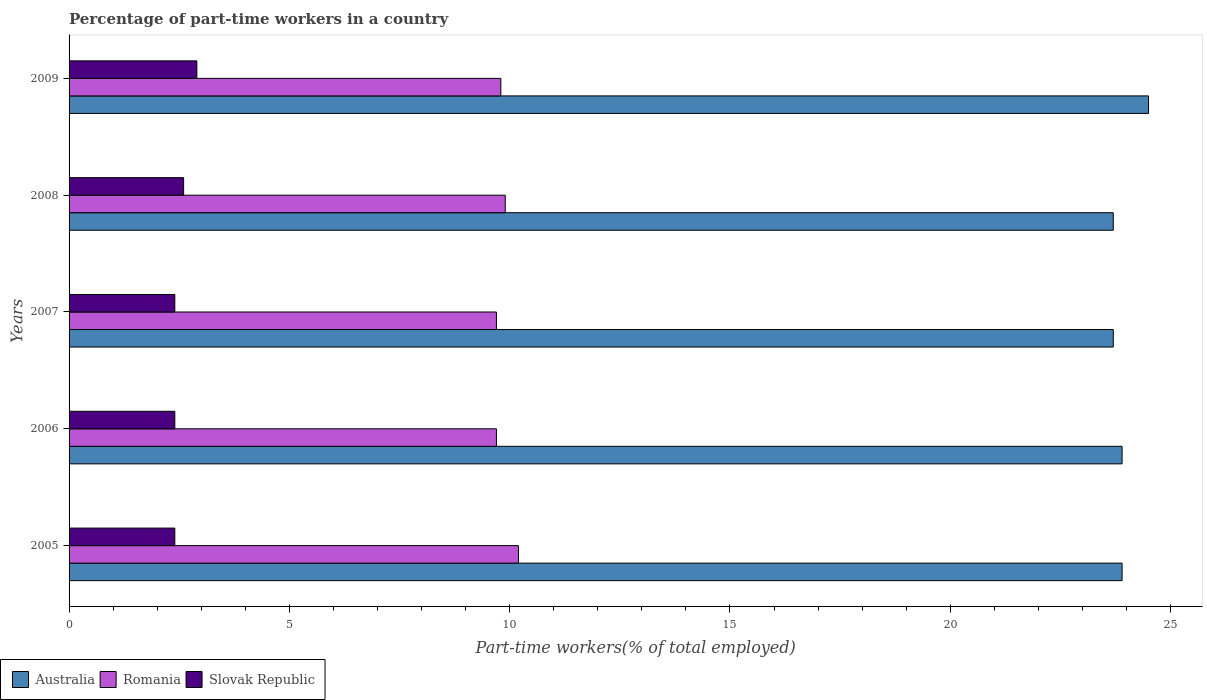Are the number of bars per tick equal to the number of legend labels?
Provide a succinct answer. Yes. Are the number of bars on each tick of the Y-axis equal?
Make the answer very short. Yes. What is the percentage of part-time workers in Slovak Republic in 2005?
Offer a very short reply. 2.4. Across all years, what is the maximum percentage of part-time workers in Romania?
Your answer should be compact. 10.2. Across all years, what is the minimum percentage of part-time workers in Romania?
Offer a very short reply. 9.7. In which year was the percentage of part-time workers in Slovak Republic maximum?
Offer a terse response. 2009. In which year was the percentage of part-time workers in Romania minimum?
Ensure brevity in your answer.  2006. What is the total percentage of part-time workers in Slovak Republic in the graph?
Make the answer very short. 12.7. What is the difference between the percentage of part-time workers in Romania in 2007 and that in 2009?
Your answer should be very brief. -0.1. What is the difference between the percentage of part-time workers in Australia in 2006 and the percentage of part-time workers in Slovak Republic in 2008?
Keep it short and to the point. 21.3. What is the average percentage of part-time workers in Romania per year?
Make the answer very short. 9.86. In the year 2005, what is the difference between the percentage of part-time workers in Slovak Republic and percentage of part-time workers in Romania?
Offer a terse response. -7.8. What is the ratio of the percentage of part-time workers in Australia in 2005 to that in 2008?
Your answer should be compact. 1.01. Is the percentage of part-time workers in Australia in 2007 less than that in 2009?
Give a very brief answer. Yes. What is the difference between the highest and the second highest percentage of part-time workers in Romania?
Offer a very short reply. 0.3. What is the difference between the highest and the lowest percentage of part-time workers in Australia?
Ensure brevity in your answer.  0.8. What does the 1st bar from the top in 2006 represents?
Ensure brevity in your answer.  Slovak Republic. What does the 2nd bar from the bottom in 2005 represents?
Your response must be concise. Romania. Is it the case that in every year, the sum of the percentage of part-time workers in Slovak Republic and percentage of part-time workers in Australia is greater than the percentage of part-time workers in Romania?
Your response must be concise. Yes. How many bars are there?
Provide a short and direct response. 15. Are all the bars in the graph horizontal?
Your answer should be very brief. Yes. What is the title of the graph?
Your answer should be very brief. Percentage of part-time workers in a country. What is the label or title of the X-axis?
Your answer should be compact. Part-time workers(% of total employed). What is the Part-time workers(% of total employed) in Australia in 2005?
Give a very brief answer. 23.9. What is the Part-time workers(% of total employed) in Romania in 2005?
Ensure brevity in your answer.  10.2. What is the Part-time workers(% of total employed) of Slovak Republic in 2005?
Offer a terse response. 2.4. What is the Part-time workers(% of total employed) of Australia in 2006?
Make the answer very short. 23.9. What is the Part-time workers(% of total employed) of Romania in 2006?
Your answer should be compact. 9.7. What is the Part-time workers(% of total employed) of Slovak Republic in 2006?
Offer a very short reply. 2.4. What is the Part-time workers(% of total employed) of Australia in 2007?
Offer a very short reply. 23.7. What is the Part-time workers(% of total employed) of Romania in 2007?
Your answer should be very brief. 9.7. What is the Part-time workers(% of total employed) of Slovak Republic in 2007?
Keep it short and to the point. 2.4. What is the Part-time workers(% of total employed) in Australia in 2008?
Make the answer very short. 23.7. What is the Part-time workers(% of total employed) in Romania in 2008?
Offer a terse response. 9.9. What is the Part-time workers(% of total employed) of Slovak Republic in 2008?
Provide a succinct answer. 2.6. What is the Part-time workers(% of total employed) of Romania in 2009?
Your answer should be compact. 9.8. What is the Part-time workers(% of total employed) of Slovak Republic in 2009?
Keep it short and to the point. 2.9. Across all years, what is the maximum Part-time workers(% of total employed) in Romania?
Ensure brevity in your answer.  10.2. Across all years, what is the maximum Part-time workers(% of total employed) of Slovak Republic?
Offer a very short reply. 2.9. Across all years, what is the minimum Part-time workers(% of total employed) of Australia?
Make the answer very short. 23.7. Across all years, what is the minimum Part-time workers(% of total employed) of Romania?
Your answer should be very brief. 9.7. Across all years, what is the minimum Part-time workers(% of total employed) of Slovak Republic?
Offer a very short reply. 2.4. What is the total Part-time workers(% of total employed) of Australia in the graph?
Offer a terse response. 119.7. What is the total Part-time workers(% of total employed) of Romania in the graph?
Keep it short and to the point. 49.3. What is the difference between the Part-time workers(% of total employed) in Romania in 2005 and that in 2006?
Provide a short and direct response. 0.5. What is the difference between the Part-time workers(% of total employed) in Slovak Republic in 2005 and that in 2006?
Offer a very short reply. 0. What is the difference between the Part-time workers(% of total employed) in Australia in 2005 and that in 2007?
Ensure brevity in your answer.  0.2. What is the difference between the Part-time workers(% of total employed) of Slovak Republic in 2005 and that in 2007?
Your response must be concise. 0. What is the difference between the Part-time workers(% of total employed) of Romania in 2005 and that in 2008?
Provide a short and direct response. 0.3. What is the difference between the Part-time workers(% of total employed) in Australia in 2005 and that in 2009?
Offer a very short reply. -0.6. What is the difference between the Part-time workers(% of total employed) of Romania in 2005 and that in 2009?
Your answer should be compact. 0.4. What is the difference between the Part-time workers(% of total employed) of Slovak Republic in 2005 and that in 2009?
Offer a very short reply. -0.5. What is the difference between the Part-time workers(% of total employed) in Australia in 2006 and that in 2007?
Offer a terse response. 0.2. What is the difference between the Part-time workers(% of total employed) of Australia in 2006 and that in 2008?
Your response must be concise. 0.2. What is the difference between the Part-time workers(% of total employed) of Slovak Republic in 2006 and that in 2008?
Provide a succinct answer. -0.2. What is the difference between the Part-time workers(% of total employed) in Australia in 2006 and that in 2009?
Ensure brevity in your answer.  -0.6. What is the difference between the Part-time workers(% of total employed) in Romania in 2006 and that in 2009?
Your response must be concise. -0.1. What is the difference between the Part-time workers(% of total employed) in Slovak Republic in 2006 and that in 2009?
Offer a very short reply. -0.5. What is the difference between the Part-time workers(% of total employed) of Australia in 2007 and that in 2008?
Your answer should be compact. 0. What is the difference between the Part-time workers(% of total employed) in Australia in 2008 and that in 2009?
Ensure brevity in your answer.  -0.8. What is the difference between the Part-time workers(% of total employed) in Slovak Republic in 2008 and that in 2009?
Ensure brevity in your answer.  -0.3. What is the difference between the Part-time workers(% of total employed) in Australia in 2005 and the Part-time workers(% of total employed) in Romania in 2006?
Give a very brief answer. 14.2. What is the difference between the Part-time workers(% of total employed) in Australia in 2005 and the Part-time workers(% of total employed) in Slovak Republic in 2006?
Offer a terse response. 21.5. What is the difference between the Part-time workers(% of total employed) in Romania in 2005 and the Part-time workers(% of total employed) in Slovak Republic in 2006?
Make the answer very short. 7.8. What is the difference between the Part-time workers(% of total employed) in Australia in 2005 and the Part-time workers(% of total employed) in Romania in 2007?
Offer a very short reply. 14.2. What is the difference between the Part-time workers(% of total employed) of Australia in 2005 and the Part-time workers(% of total employed) of Slovak Republic in 2007?
Offer a very short reply. 21.5. What is the difference between the Part-time workers(% of total employed) of Australia in 2005 and the Part-time workers(% of total employed) of Romania in 2008?
Make the answer very short. 14. What is the difference between the Part-time workers(% of total employed) of Australia in 2005 and the Part-time workers(% of total employed) of Slovak Republic in 2008?
Offer a terse response. 21.3. What is the difference between the Part-time workers(% of total employed) in Australia in 2005 and the Part-time workers(% of total employed) in Slovak Republic in 2009?
Your answer should be very brief. 21. What is the difference between the Part-time workers(% of total employed) of Romania in 2005 and the Part-time workers(% of total employed) of Slovak Republic in 2009?
Offer a very short reply. 7.3. What is the difference between the Part-time workers(% of total employed) in Australia in 2006 and the Part-time workers(% of total employed) in Romania in 2007?
Your answer should be compact. 14.2. What is the difference between the Part-time workers(% of total employed) of Romania in 2006 and the Part-time workers(% of total employed) of Slovak Republic in 2007?
Provide a succinct answer. 7.3. What is the difference between the Part-time workers(% of total employed) in Australia in 2006 and the Part-time workers(% of total employed) in Romania in 2008?
Provide a short and direct response. 14. What is the difference between the Part-time workers(% of total employed) in Australia in 2006 and the Part-time workers(% of total employed) in Slovak Republic in 2008?
Offer a very short reply. 21.3. What is the difference between the Part-time workers(% of total employed) in Australia in 2006 and the Part-time workers(% of total employed) in Romania in 2009?
Offer a terse response. 14.1. What is the difference between the Part-time workers(% of total employed) in Romania in 2006 and the Part-time workers(% of total employed) in Slovak Republic in 2009?
Provide a short and direct response. 6.8. What is the difference between the Part-time workers(% of total employed) of Australia in 2007 and the Part-time workers(% of total employed) of Slovak Republic in 2008?
Your answer should be very brief. 21.1. What is the difference between the Part-time workers(% of total employed) in Australia in 2007 and the Part-time workers(% of total employed) in Slovak Republic in 2009?
Provide a succinct answer. 20.8. What is the difference between the Part-time workers(% of total employed) in Romania in 2007 and the Part-time workers(% of total employed) in Slovak Republic in 2009?
Your answer should be very brief. 6.8. What is the difference between the Part-time workers(% of total employed) of Australia in 2008 and the Part-time workers(% of total employed) of Romania in 2009?
Provide a succinct answer. 13.9. What is the difference between the Part-time workers(% of total employed) of Australia in 2008 and the Part-time workers(% of total employed) of Slovak Republic in 2009?
Your response must be concise. 20.8. What is the average Part-time workers(% of total employed) in Australia per year?
Your response must be concise. 23.94. What is the average Part-time workers(% of total employed) of Romania per year?
Offer a terse response. 9.86. What is the average Part-time workers(% of total employed) of Slovak Republic per year?
Your answer should be very brief. 2.54. In the year 2005, what is the difference between the Part-time workers(% of total employed) in Australia and Part-time workers(% of total employed) in Romania?
Make the answer very short. 13.7. In the year 2005, what is the difference between the Part-time workers(% of total employed) in Romania and Part-time workers(% of total employed) in Slovak Republic?
Offer a terse response. 7.8. In the year 2006, what is the difference between the Part-time workers(% of total employed) of Australia and Part-time workers(% of total employed) of Slovak Republic?
Offer a terse response. 21.5. In the year 2006, what is the difference between the Part-time workers(% of total employed) of Romania and Part-time workers(% of total employed) of Slovak Republic?
Provide a succinct answer. 7.3. In the year 2007, what is the difference between the Part-time workers(% of total employed) of Australia and Part-time workers(% of total employed) of Romania?
Your response must be concise. 14. In the year 2007, what is the difference between the Part-time workers(% of total employed) in Australia and Part-time workers(% of total employed) in Slovak Republic?
Keep it short and to the point. 21.3. In the year 2007, what is the difference between the Part-time workers(% of total employed) in Romania and Part-time workers(% of total employed) in Slovak Republic?
Make the answer very short. 7.3. In the year 2008, what is the difference between the Part-time workers(% of total employed) in Australia and Part-time workers(% of total employed) in Slovak Republic?
Provide a succinct answer. 21.1. In the year 2009, what is the difference between the Part-time workers(% of total employed) in Australia and Part-time workers(% of total employed) in Romania?
Your answer should be very brief. 14.7. In the year 2009, what is the difference between the Part-time workers(% of total employed) in Australia and Part-time workers(% of total employed) in Slovak Republic?
Your response must be concise. 21.6. What is the ratio of the Part-time workers(% of total employed) in Romania in 2005 to that in 2006?
Ensure brevity in your answer.  1.05. What is the ratio of the Part-time workers(% of total employed) in Slovak Republic in 2005 to that in 2006?
Give a very brief answer. 1. What is the ratio of the Part-time workers(% of total employed) of Australia in 2005 to that in 2007?
Offer a terse response. 1.01. What is the ratio of the Part-time workers(% of total employed) of Romania in 2005 to that in 2007?
Make the answer very short. 1.05. What is the ratio of the Part-time workers(% of total employed) in Australia in 2005 to that in 2008?
Your response must be concise. 1.01. What is the ratio of the Part-time workers(% of total employed) of Romania in 2005 to that in 2008?
Make the answer very short. 1.03. What is the ratio of the Part-time workers(% of total employed) in Australia in 2005 to that in 2009?
Ensure brevity in your answer.  0.98. What is the ratio of the Part-time workers(% of total employed) in Romania in 2005 to that in 2009?
Your answer should be very brief. 1.04. What is the ratio of the Part-time workers(% of total employed) in Slovak Republic in 2005 to that in 2009?
Offer a terse response. 0.83. What is the ratio of the Part-time workers(% of total employed) of Australia in 2006 to that in 2007?
Keep it short and to the point. 1.01. What is the ratio of the Part-time workers(% of total employed) of Slovak Republic in 2006 to that in 2007?
Keep it short and to the point. 1. What is the ratio of the Part-time workers(% of total employed) of Australia in 2006 to that in 2008?
Offer a very short reply. 1.01. What is the ratio of the Part-time workers(% of total employed) of Romania in 2006 to that in 2008?
Give a very brief answer. 0.98. What is the ratio of the Part-time workers(% of total employed) of Australia in 2006 to that in 2009?
Make the answer very short. 0.98. What is the ratio of the Part-time workers(% of total employed) in Romania in 2006 to that in 2009?
Provide a succinct answer. 0.99. What is the ratio of the Part-time workers(% of total employed) of Slovak Republic in 2006 to that in 2009?
Offer a terse response. 0.83. What is the ratio of the Part-time workers(% of total employed) in Romania in 2007 to that in 2008?
Offer a very short reply. 0.98. What is the ratio of the Part-time workers(% of total employed) of Slovak Republic in 2007 to that in 2008?
Offer a terse response. 0.92. What is the ratio of the Part-time workers(% of total employed) in Australia in 2007 to that in 2009?
Offer a very short reply. 0.97. What is the ratio of the Part-time workers(% of total employed) of Romania in 2007 to that in 2009?
Provide a succinct answer. 0.99. What is the ratio of the Part-time workers(% of total employed) of Slovak Republic in 2007 to that in 2009?
Keep it short and to the point. 0.83. What is the ratio of the Part-time workers(% of total employed) in Australia in 2008 to that in 2009?
Offer a very short reply. 0.97. What is the ratio of the Part-time workers(% of total employed) of Romania in 2008 to that in 2009?
Provide a succinct answer. 1.01. What is the ratio of the Part-time workers(% of total employed) of Slovak Republic in 2008 to that in 2009?
Keep it short and to the point. 0.9. 